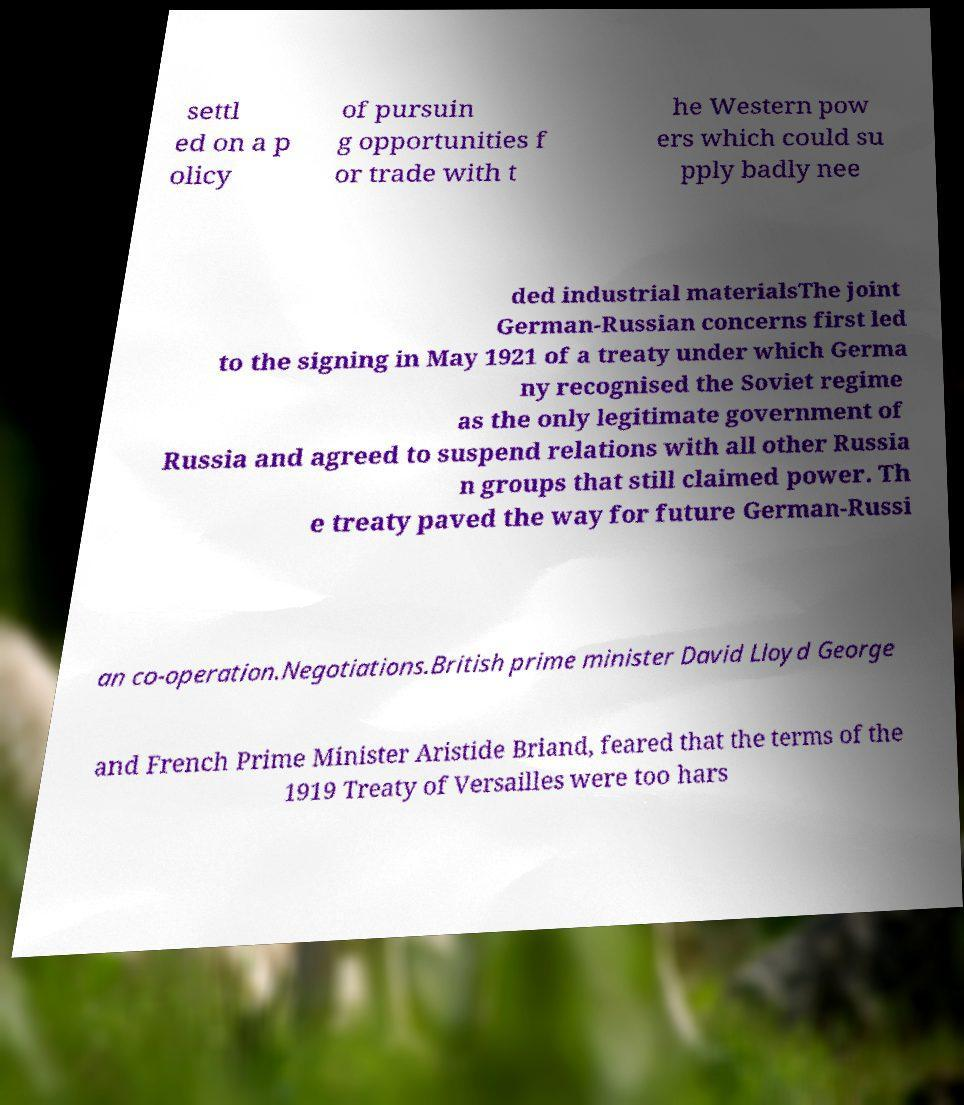For documentation purposes, I need the text within this image transcribed. Could you provide that? settl ed on a p olicy of pursuin g opportunities f or trade with t he Western pow ers which could su pply badly nee ded industrial materialsThe joint German-Russian concerns first led to the signing in May 1921 of a treaty under which Germa ny recognised the Soviet regime as the only legitimate government of Russia and agreed to suspend relations with all other Russia n groups that still claimed power. Th e treaty paved the way for future German-Russi an co-operation.Negotiations.British prime minister David Lloyd George and French Prime Minister Aristide Briand, feared that the terms of the 1919 Treaty of Versailles were too hars 